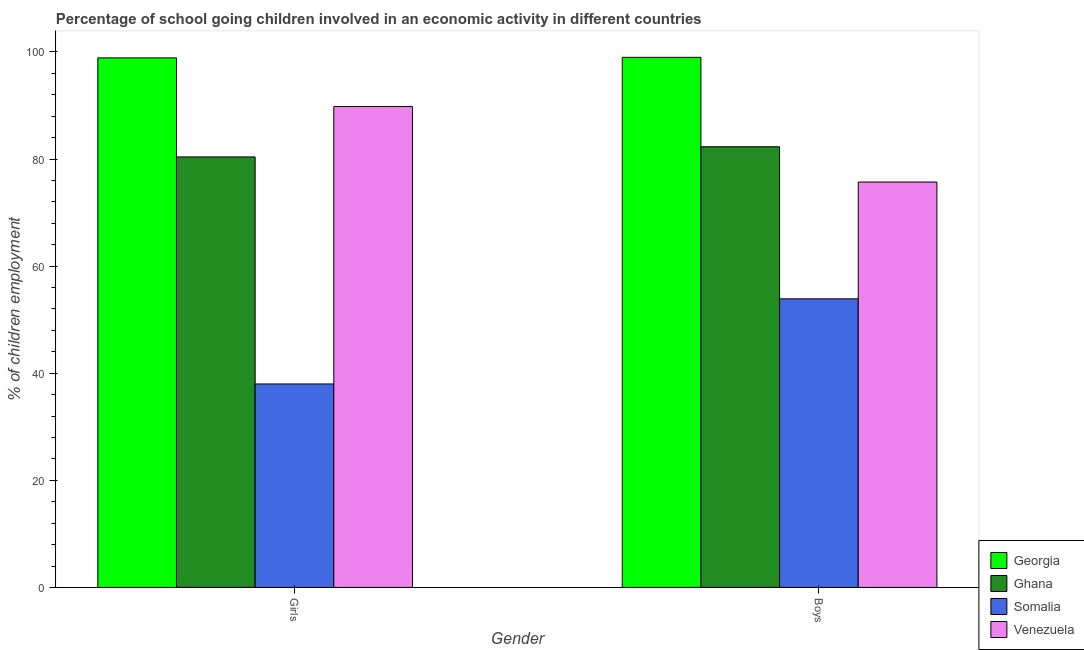How many different coloured bars are there?
Give a very brief answer. 4. How many groups of bars are there?
Provide a succinct answer. 2. Are the number of bars on each tick of the X-axis equal?
Provide a short and direct response. Yes. How many bars are there on the 2nd tick from the left?
Offer a very short reply. 4. How many bars are there on the 1st tick from the right?
Give a very brief answer. 4. What is the label of the 1st group of bars from the left?
Provide a succinct answer. Girls. What is the percentage of school going boys in Somalia?
Give a very brief answer. 53.9. Across all countries, what is the maximum percentage of school going girls?
Provide a succinct answer. 98.9. Across all countries, what is the minimum percentage of school going boys?
Your response must be concise. 53.9. In which country was the percentage of school going boys maximum?
Offer a very short reply. Georgia. In which country was the percentage of school going boys minimum?
Ensure brevity in your answer.  Somalia. What is the total percentage of school going boys in the graph?
Give a very brief answer. 310.91. What is the difference between the percentage of school going boys in Somalia and that in Ghana?
Ensure brevity in your answer.  -28.4. What is the difference between the percentage of school going girls in Venezuela and the percentage of school going boys in Somalia?
Offer a very short reply. 35.91. What is the average percentage of school going boys per country?
Give a very brief answer. 77.73. What is the difference between the percentage of school going girls and percentage of school going boys in Georgia?
Your response must be concise. -0.1. In how many countries, is the percentage of school going girls greater than 56 %?
Give a very brief answer. 3. What is the ratio of the percentage of school going girls in Ghana to that in Georgia?
Give a very brief answer. 0.81. Is the percentage of school going girls in Georgia less than that in Somalia?
Give a very brief answer. No. In how many countries, is the percentage of school going boys greater than the average percentage of school going boys taken over all countries?
Offer a terse response. 2. What does the 1st bar from the left in Boys represents?
Give a very brief answer. Georgia. What does the 1st bar from the right in Boys represents?
Keep it short and to the point. Venezuela. How many bars are there?
Provide a succinct answer. 8. How many countries are there in the graph?
Your answer should be very brief. 4. Does the graph contain any zero values?
Your response must be concise. No. Where does the legend appear in the graph?
Your response must be concise. Bottom right. What is the title of the graph?
Your answer should be very brief. Percentage of school going children involved in an economic activity in different countries. What is the label or title of the Y-axis?
Make the answer very short. % of children employment. What is the % of children employment of Georgia in Girls?
Provide a short and direct response. 98.9. What is the % of children employment of Ghana in Girls?
Ensure brevity in your answer.  80.4. What is the % of children employment of Somalia in Girls?
Provide a short and direct response. 38. What is the % of children employment of Venezuela in Girls?
Ensure brevity in your answer.  89.81. What is the % of children employment in Georgia in Boys?
Provide a short and direct response. 99. What is the % of children employment in Ghana in Boys?
Make the answer very short. 82.3. What is the % of children employment of Somalia in Boys?
Provide a succinct answer. 53.9. What is the % of children employment in Venezuela in Boys?
Offer a very short reply. 75.71. Across all Gender, what is the maximum % of children employment in Ghana?
Your response must be concise. 82.3. Across all Gender, what is the maximum % of children employment in Somalia?
Give a very brief answer. 53.9. Across all Gender, what is the maximum % of children employment in Venezuela?
Provide a short and direct response. 89.81. Across all Gender, what is the minimum % of children employment of Georgia?
Give a very brief answer. 98.9. Across all Gender, what is the minimum % of children employment in Ghana?
Your answer should be very brief. 80.4. Across all Gender, what is the minimum % of children employment in Venezuela?
Provide a short and direct response. 75.71. What is the total % of children employment in Georgia in the graph?
Offer a very short reply. 197.9. What is the total % of children employment in Ghana in the graph?
Give a very brief answer. 162.7. What is the total % of children employment in Somalia in the graph?
Make the answer very short. 91.9. What is the total % of children employment in Venezuela in the graph?
Offer a terse response. 165.52. What is the difference between the % of children employment in Ghana in Girls and that in Boys?
Offer a terse response. -1.9. What is the difference between the % of children employment of Somalia in Girls and that in Boys?
Your response must be concise. -15.9. What is the difference between the % of children employment in Venezuela in Girls and that in Boys?
Keep it short and to the point. 14.09. What is the difference between the % of children employment of Georgia in Girls and the % of children employment of Ghana in Boys?
Provide a succinct answer. 16.6. What is the difference between the % of children employment of Georgia in Girls and the % of children employment of Venezuela in Boys?
Make the answer very short. 23.19. What is the difference between the % of children employment of Ghana in Girls and the % of children employment of Venezuela in Boys?
Ensure brevity in your answer.  4.69. What is the difference between the % of children employment of Somalia in Girls and the % of children employment of Venezuela in Boys?
Your response must be concise. -37.71. What is the average % of children employment in Georgia per Gender?
Offer a terse response. 98.95. What is the average % of children employment in Ghana per Gender?
Provide a succinct answer. 81.35. What is the average % of children employment in Somalia per Gender?
Give a very brief answer. 45.95. What is the average % of children employment of Venezuela per Gender?
Give a very brief answer. 82.76. What is the difference between the % of children employment of Georgia and % of children employment of Ghana in Girls?
Your response must be concise. 18.5. What is the difference between the % of children employment in Georgia and % of children employment in Somalia in Girls?
Offer a very short reply. 60.9. What is the difference between the % of children employment of Georgia and % of children employment of Venezuela in Girls?
Provide a short and direct response. 9.09. What is the difference between the % of children employment of Ghana and % of children employment of Somalia in Girls?
Your answer should be very brief. 42.4. What is the difference between the % of children employment of Ghana and % of children employment of Venezuela in Girls?
Offer a terse response. -9.41. What is the difference between the % of children employment in Somalia and % of children employment in Venezuela in Girls?
Ensure brevity in your answer.  -51.81. What is the difference between the % of children employment in Georgia and % of children employment in Somalia in Boys?
Give a very brief answer. 45.1. What is the difference between the % of children employment in Georgia and % of children employment in Venezuela in Boys?
Your response must be concise. 23.29. What is the difference between the % of children employment of Ghana and % of children employment of Somalia in Boys?
Offer a terse response. 28.4. What is the difference between the % of children employment of Ghana and % of children employment of Venezuela in Boys?
Ensure brevity in your answer.  6.59. What is the difference between the % of children employment of Somalia and % of children employment of Venezuela in Boys?
Give a very brief answer. -21.81. What is the ratio of the % of children employment of Georgia in Girls to that in Boys?
Ensure brevity in your answer.  1. What is the ratio of the % of children employment of Ghana in Girls to that in Boys?
Your answer should be compact. 0.98. What is the ratio of the % of children employment in Somalia in Girls to that in Boys?
Give a very brief answer. 0.7. What is the ratio of the % of children employment in Venezuela in Girls to that in Boys?
Make the answer very short. 1.19. What is the difference between the highest and the second highest % of children employment of Ghana?
Your response must be concise. 1.9. What is the difference between the highest and the second highest % of children employment of Somalia?
Provide a short and direct response. 15.9. What is the difference between the highest and the second highest % of children employment in Venezuela?
Your answer should be very brief. 14.09. What is the difference between the highest and the lowest % of children employment in Ghana?
Provide a succinct answer. 1.9. What is the difference between the highest and the lowest % of children employment in Somalia?
Keep it short and to the point. 15.9. What is the difference between the highest and the lowest % of children employment in Venezuela?
Provide a short and direct response. 14.09. 